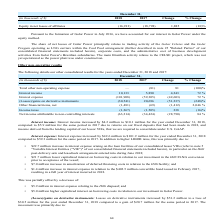From Golar Lng's financial document, In which years was the consolidated results recorded for? The document shows two values: 2017 and 2018. From the document: "December 31, (in thousands of $) 2018 2017 Change % Change December 31, (in thousands of $) 2018 2017 Change % Change..." Also, What was the net income attributable to non-controlling shareholders who hold interests in Hilli LLC and Hilli Corp in 2017? Based on the financial document, the answer is $1.5 million. Also, What accounted for the increase in interest income? Due to returns on our fixed deposits that had been made in 2018, and income derived from the lending capital of our lessor VIEs, that we are required to consolidate under U.S. GAAP. The document states: "pared to $5.9 million for the same period in 2017 due to returns on our fixed deposits that had been made in 2018, and income derived from the lending..." Additionally, Which year has a higher income tax? According to the financial document, 2017. The relevant text states: "December 31, (in thousands of $) 2018 2017 Change % Change..." Also, can you calculate: What was the change in net unrealized gains on the interest rate swaps between 2017 and 2018? Based on the calculation: $0.6 million - $6.6 million , the result is -6 (in millions). The key data points involved are: 0.6, 6.6. Also, can you calculate: What was the percentage change net income attributable to non-controlling shareholders who hold interests in Hilli LLC and Hilli Corp between 2017 and 2018? To answer this question, I need to perform calculations using the financial data. The calculation is: (19.7 - 1.5)/1.5 , which equals 1213.33 (percentage). The key data points involved are: 1.5, 19.7. 